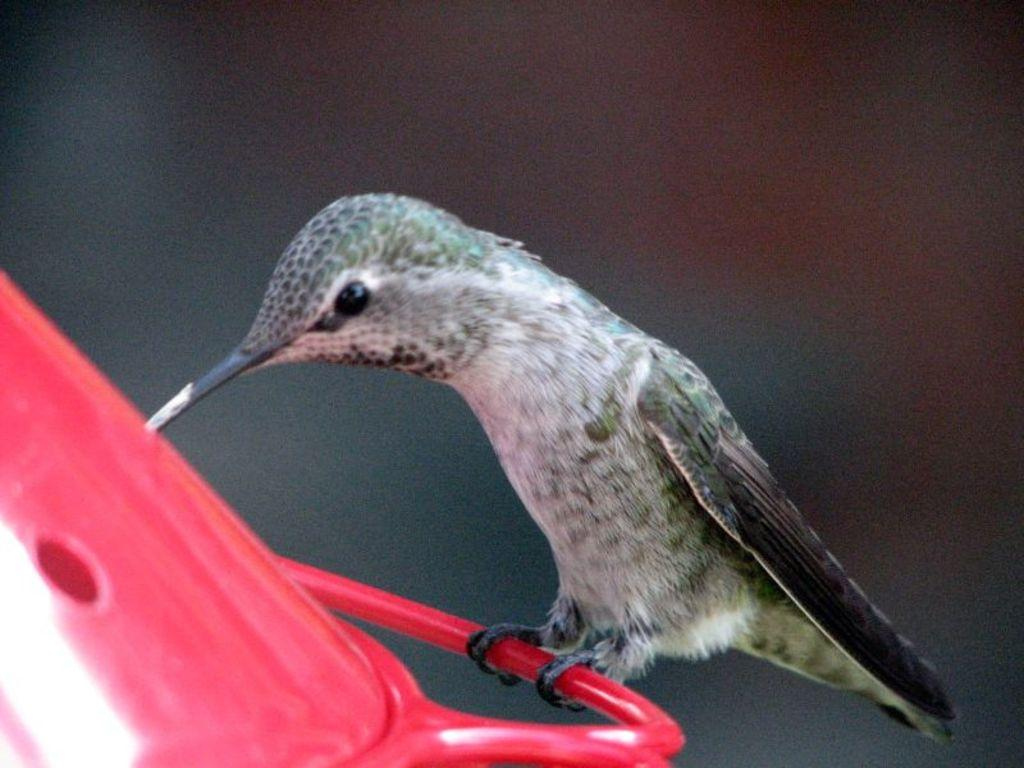What type of animal is in the image? There is a small bird in the image. What is the bird standing on? The bird is standing on a container. Can you describe the background of the image? The background of the image is blurry. What type of lead can be seen in the image? There is no lead present in the image; it features a small bird standing on a container with a blurry background. 